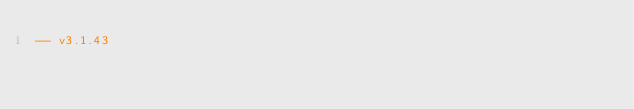<code> <loc_0><loc_0><loc_500><loc_500><_SQL_>-- v3.1.43
</code> 